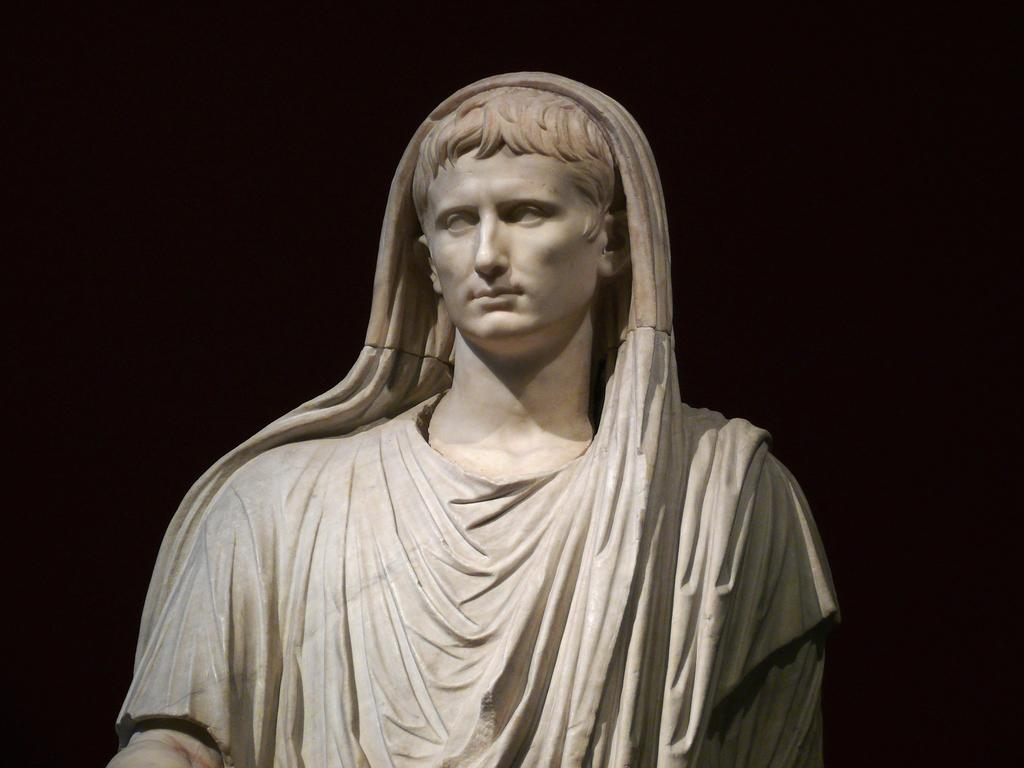What is the main subject of the image? There is a white color sculpture of a woman in the image. Where is the sculpture located in the image? The sculpture is in the front of the image. What color can be seen in the background of the image? There is black color visible in the background of the image. How many balls are being used by the beast in the image? There is no beast or balls present in the image; it features a white color sculpture of a woman. 